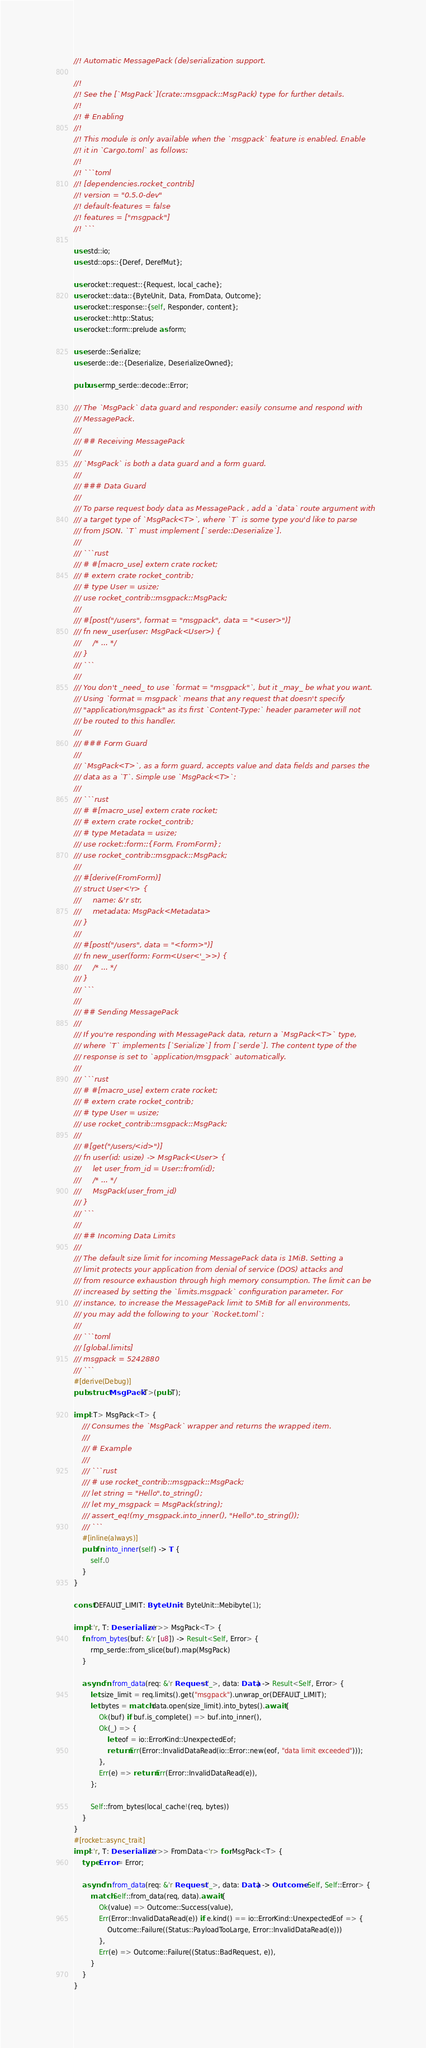<code> <loc_0><loc_0><loc_500><loc_500><_Rust_>//! Automatic MessagePack (de)serialization support.

//!
//! See the [`MsgPack`](crate::msgpack::MsgPack) type for further details.
//!
//! # Enabling
//!
//! This module is only available when the `msgpack` feature is enabled. Enable
//! it in `Cargo.toml` as follows:
//!
//! ```toml
//! [dependencies.rocket_contrib]
//! version = "0.5.0-dev"
//! default-features = false
//! features = ["msgpack"]
//! ```

use std::io;
use std::ops::{Deref, DerefMut};

use rocket::request::{Request, local_cache};
use rocket::data::{ByteUnit, Data, FromData, Outcome};
use rocket::response::{self, Responder, content};
use rocket::http::Status;
use rocket::form::prelude as form;

use serde::Serialize;
use serde::de::{Deserialize, DeserializeOwned};

pub use rmp_serde::decode::Error;

/// The `MsgPack` data guard and responder: easily consume and respond with
/// MessagePack.
///
/// ## Receiving MessagePack
///
/// `MsgPack` is both a data guard and a form guard.
///
/// ### Data Guard
///
/// To parse request body data as MessagePack , add a `data` route argument with
/// a target type of `MsgPack<T>`, where `T` is some type you'd like to parse
/// from JSON. `T` must implement [`serde::Deserialize`].
///
/// ```rust
/// # #[macro_use] extern crate rocket;
/// # extern crate rocket_contrib;
/// # type User = usize;
/// use rocket_contrib::msgpack::MsgPack;
///
/// #[post("/users", format = "msgpack", data = "<user>")]
/// fn new_user(user: MsgPack<User>) {
///     /* ... */
/// }
/// ```
///
/// You don't _need_ to use `format = "msgpack"`, but it _may_ be what you want.
/// Using `format = msgpack` means that any request that doesn't specify
/// "application/msgpack" as its first `Content-Type:` header parameter will not
/// be routed to this handler.
///
/// ### Form Guard
///
/// `MsgPack<T>`, as a form guard, accepts value and data fields and parses the
/// data as a `T`. Simple use `MsgPack<T>`:
///
/// ```rust
/// # #[macro_use] extern crate rocket;
/// # extern crate rocket_contrib;
/// # type Metadata = usize;
/// use rocket::form::{Form, FromForm};
/// use rocket_contrib::msgpack::MsgPack;
///
/// #[derive(FromForm)]
/// struct User<'r> {
///     name: &'r str,
///     metadata: MsgPack<Metadata>
/// }
///
/// #[post("/users", data = "<form>")]
/// fn new_user(form: Form<User<'_>>) {
///     /* ... */
/// }
/// ```
///
/// ## Sending MessagePack
///
/// If you're responding with MessagePack data, return a `MsgPack<T>` type,
/// where `T` implements [`Serialize`] from [`serde`]. The content type of the
/// response is set to `application/msgpack` automatically.
///
/// ```rust
/// # #[macro_use] extern crate rocket;
/// # extern crate rocket_contrib;
/// # type User = usize;
/// use rocket_contrib::msgpack::MsgPack;
///
/// #[get("/users/<id>")]
/// fn user(id: usize) -> MsgPack<User> {
///     let user_from_id = User::from(id);
///     /* ... */
///     MsgPack(user_from_id)
/// }
/// ```
///
/// ## Incoming Data Limits
///
/// The default size limit for incoming MessagePack data is 1MiB. Setting a
/// limit protects your application from denial of service (DOS) attacks and
/// from resource exhaustion through high memory consumption. The limit can be
/// increased by setting the `limits.msgpack` configuration parameter. For
/// instance, to increase the MessagePack limit to 5MiB for all environments,
/// you may add the following to your `Rocket.toml`:
///
/// ```toml
/// [global.limits]
/// msgpack = 5242880
/// ```
#[derive(Debug)]
pub struct MsgPack<T>(pub T);

impl<T> MsgPack<T> {
    /// Consumes the `MsgPack` wrapper and returns the wrapped item.
    ///
    /// # Example
    ///
    /// ```rust
    /// # use rocket_contrib::msgpack::MsgPack;
    /// let string = "Hello".to_string();
    /// let my_msgpack = MsgPack(string);
    /// assert_eq!(my_msgpack.into_inner(), "Hello".to_string());
    /// ```
    #[inline(always)]
    pub fn into_inner(self) -> T {
        self.0
    }
}

const DEFAULT_LIMIT: ByteUnit = ByteUnit::Mebibyte(1);

impl<'r, T: Deserialize<'r>> MsgPack<T> {
    fn from_bytes(buf: &'r [u8]) -> Result<Self, Error> {
        rmp_serde::from_slice(buf).map(MsgPack)
    }

    async fn from_data(req: &'r Request<'_>, data: Data) -> Result<Self, Error> {
        let size_limit = req.limits().get("msgpack").unwrap_or(DEFAULT_LIMIT);
        let bytes = match data.open(size_limit).into_bytes().await {
            Ok(buf) if buf.is_complete() => buf.into_inner(),
            Ok(_) => {
                let eof = io::ErrorKind::UnexpectedEof;
                return Err(Error::InvalidDataRead(io::Error::new(eof, "data limit exceeded")));
            },
            Err(e) => return Err(Error::InvalidDataRead(e)),
        };

        Self::from_bytes(local_cache!(req, bytes))
    }
}
#[rocket::async_trait]
impl<'r, T: Deserialize<'r>> FromData<'r> for MsgPack<T> {
    type Error = Error;

    async fn from_data(req: &'r Request<'_>, data: Data) -> Outcome<Self, Self::Error> {
        match Self::from_data(req, data).await {
            Ok(value) => Outcome::Success(value),
            Err(Error::InvalidDataRead(e)) if e.kind() == io::ErrorKind::UnexpectedEof => {
                Outcome::Failure((Status::PayloadTooLarge, Error::InvalidDataRead(e)))
            },
            Err(e) => Outcome::Failure((Status::BadRequest, e)),
        }
    }
}
</code> 